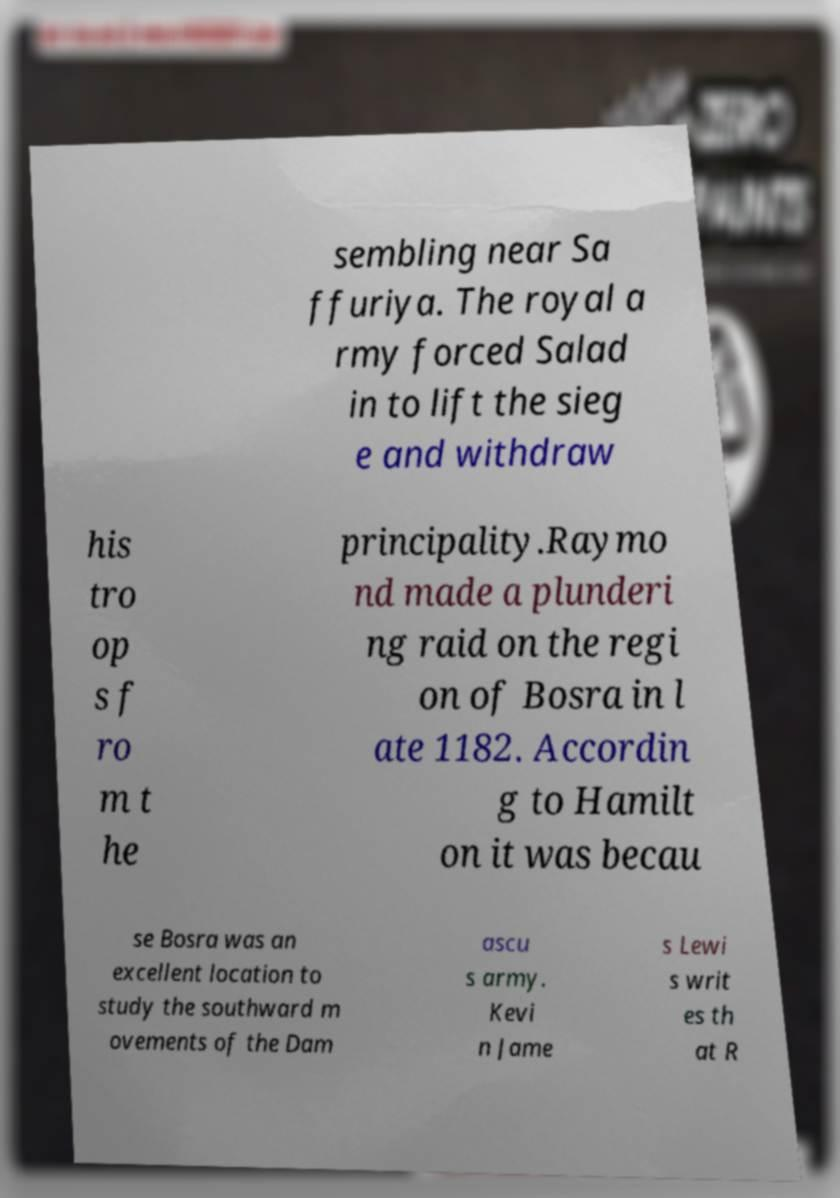I need the written content from this picture converted into text. Can you do that? sembling near Sa ffuriya. The royal a rmy forced Salad in to lift the sieg e and withdraw his tro op s f ro m t he principality.Raymo nd made a plunderi ng raid on the regi on of Bosra in l ate 1182. Accordin g to Hamilt on it was becau se Bosra was an excellent location to study the southward m ovements of the Dam ascu s army. Kevi n Jame s Lewi s writ es th at R 